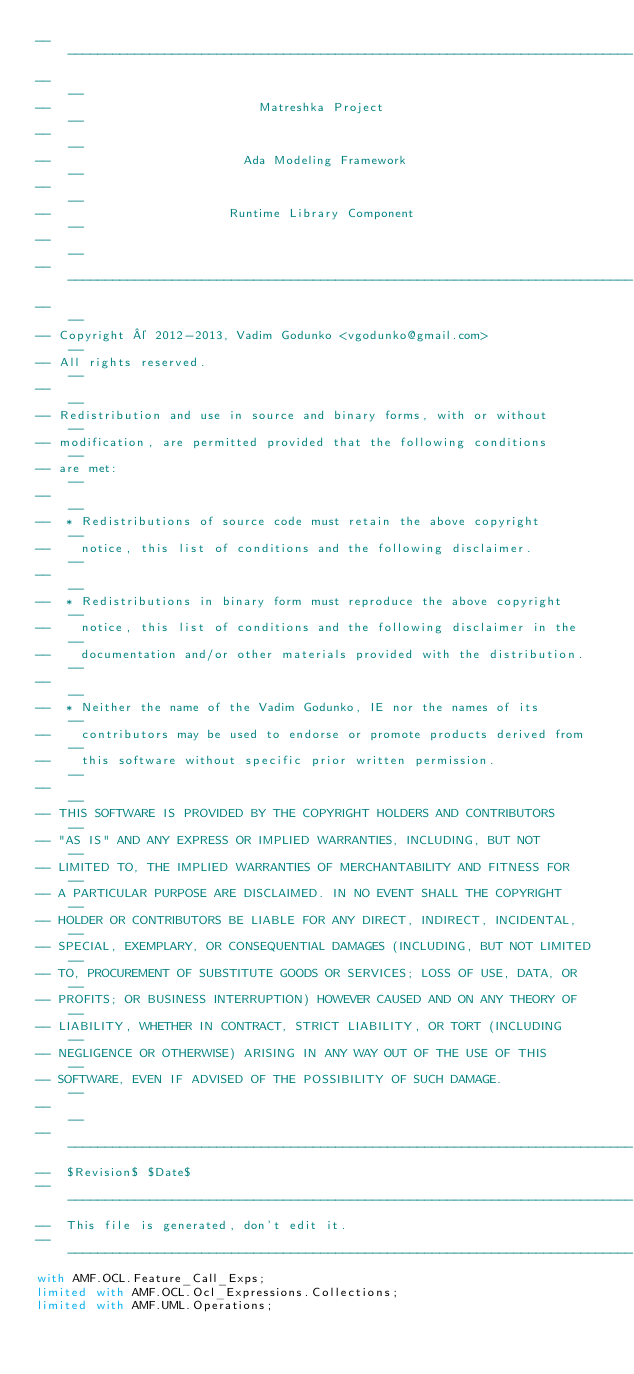Convert code to text. <code><loc_0><loc_0><loc_500><loc_500><_Ada_>------------------------------------------------------------------------------
--                                                                          --
--                            Matreshka Project                             --
--                                                                          --
--                          Ada Modeling Framework                          --
--                                                                          --
--                        Runtime Library Component                         --
--                                                                          --
------------------------------------------------------------------------------
--                                                                          --
-- Copyright © 2012-2013, Vadim Godunko <vgodunko@gmail.com>                --
-- All rights reserved.                                                     --
--                                                                          --
-- Redistribution and use in source and binary forms, with or without       --
-- modification, are permitted provided that the following conditions       --
-- are met:                                                                 --
--                                                                          --
--  * Redistributions of source code must retain the above copyright        --
--    notice, this list of conditions and the following disclaimer.         --
--                                                                          --
--  * Redistributions in binary form must reproduce the above copyright     --
--    notice, this list of conditions and the following disclaimer in the   --
--    documentation and/or other materials provided with the distribution.  --
--                                                                          --
--  * Neither the name of the Vadim Godunko, IE nor the names of its        --
--    contributors may be used to endorse or promote products derived from  --
--    this software without specific prior written permission.              --
--                                                                          --
-- THIS SOFTWARE IS PROVIDED BY THE COPYRIGHT HOLDERS AND CONTRIBUTORS      --
-- "AS IS" AND ANY EXPRESS OR IMPLIED WARRANTIES, INCLUDING, BUT NOT        --
-- LIMITED TO, THE IMPLIED WARRANTIES OF MERCHANTABILITY AND FITNESS FOR    --
-- A PARTICULAR PURPOSE ARE DISCLAIMED. IN NO EVENT SHALL THE COPYRIGHT     --
-- HOLDER OR CONTRIBUTORS BE LIABLE FOR ANY DIRECT, INDIRECT, INCIDENTAL,   --
-- SPECIAL, EXEMPLARY, OR CONSEQUENTIAL DAMAGES (INCLUDING, BUT NOT LIMITED --
-- TO, PROCUREMENT OF SUBSTITUTE GOODS OR SERVICES; LOSS OF USE, DATA, OR   --
-- PROFITS; OR BUSINESS INTERRUPTION) HOWEVER CAUSED AND ON ANY THEORY OF   --
-- LIABILITY, WHETHER IN CONTRACT, STRICT LIABILITY, OR TORT (INCLUDING     --
-- NEGLIGENCE OR OTHERWISE) ARISING IN ANY WAY OUT OF THE USE OF THIS       --
-- SOFTWARE, EVEN IF ADVISED OF THE POSSIBILITY OF SUCH DAMAGE.             --
--                                                                          --
------------------------------------------------------------------------------
--  $Revision$ $Date$
------------------------------------------------------------------------------
--  This file is generated, don't edit it.
------------------------------------------------------------------------------
with AMF.OCL.Feature_Call_Exps;
limited with AMF.OCL.Ocl_Expressions.Collections;
limited with AMF.UML.Operations;
</code> 